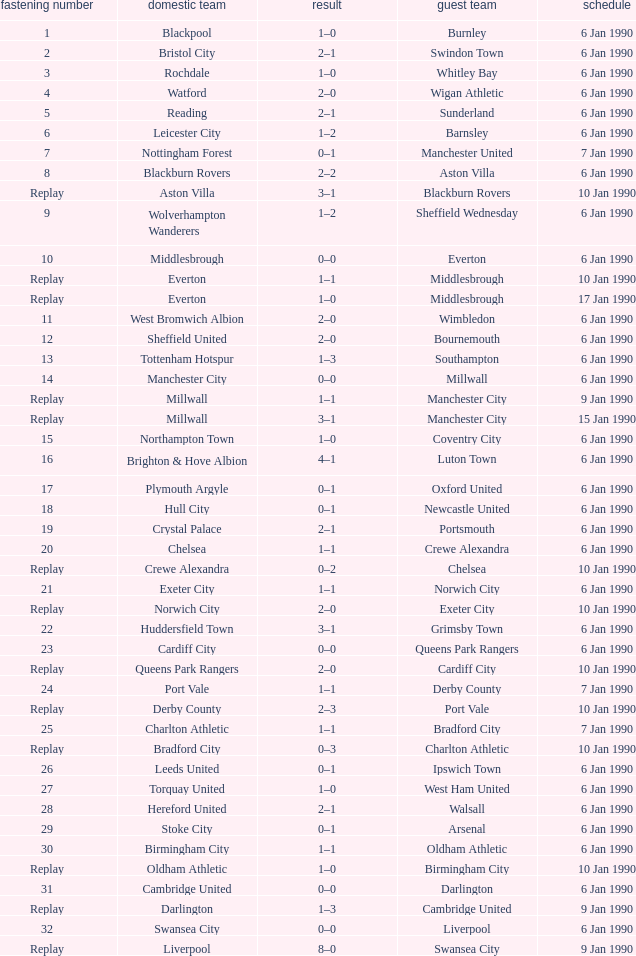What was the score of the game against away team crewe alexandra? 1–1. 